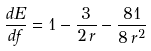<formula> <loc_0><loc_0><loc_500><loc_500>\frac { d E } { d f } = 1 - \frac { 3 } { 2 \, r } - \frac { 8 1 } { 8 \, r ^ { 2 } }</formula> 